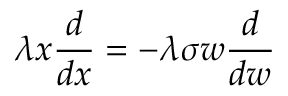Convert formula to latex. <formula><loc_0><loc_0><loc_500><loc_500>\lambda x \frac { d } { d x } = - \lambda \sigma w \frac { d } { d w }</formula> 